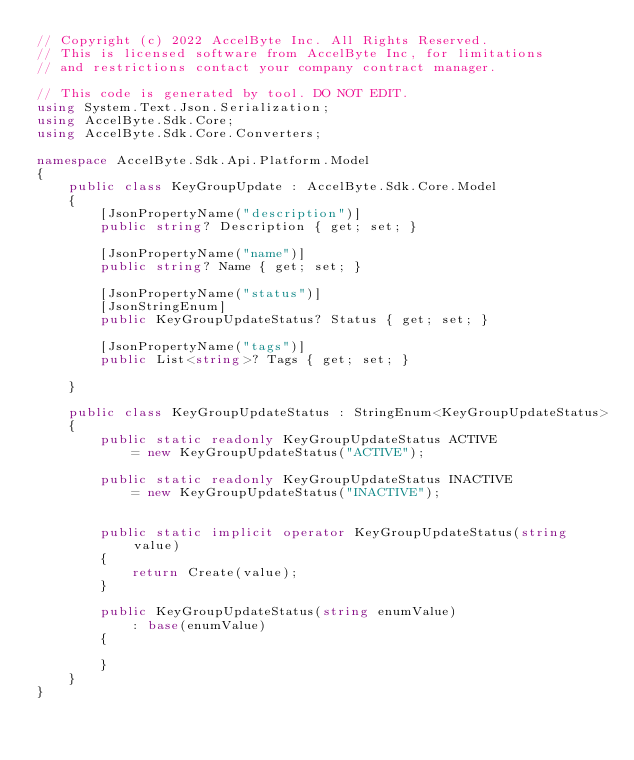<code> <loc_0><loc_0><loc_500><loc_500><_C#_>// Copyright (c) 2022 AccelByte Inc. All Rights Reserved.
// This is licensed software from AccelByte Inc, for limitations
// and restrictions contact your company contract manager.

// This code is generated by tool. DO NOT EDIT.
using System.Text.Json.Serialization;
using AccelByte.Sdk.Core;
using AccelByte.Sdk.Core.Converters;

namespace AccelByte.Sdk.Api.Platform.Model
{
    public class KeyGroupUpdate : AccelByte.Sdk.Core.Model
    {
        [JsonPropertyName("description")]
        public string? Description { get; set; }

        [JsonPropertyName("name")]
        public string? Name { get; set; }

        [JsonPropertyName("status")]
        [JsonStringEnum]
        public KeyGroupUpdateStatus? Status { get; set; }

        [JsonPropertyName("tags")]
        public List<string>? Tags { get; set; }

    }

    public class KeyGroupUpdateStatus : StringEnum<KeyGroupUpdateStatus>
    {
        public static readonly KeyGroupUpdateStatus ACTIVE
            = new KeyGroupUpdateStatus("ACTIVE");

        public static readonly KeyGroupUpdateStatus INACTIVE
            = new KeyGroupUpdateStatus("INACTIVE");


        public static implicit operator KeyGroupUpdateStatus(string value)
        {
            return Create(value);
        }

        public KeyGroupUpdateStatus(string enumValue)
            : base(enumValue)
        {

        }
    }    
}</code> 